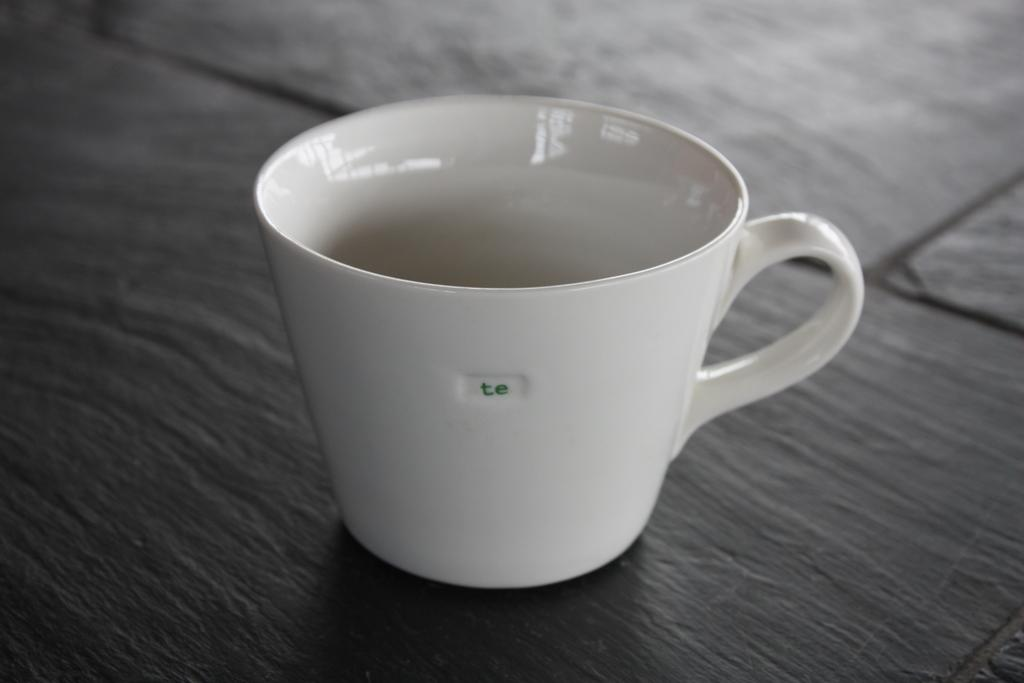<image>
Write a terse but informative summary of the picture. An empty white tea cup with the initials te embossed on it's side sits on a tiled table. 